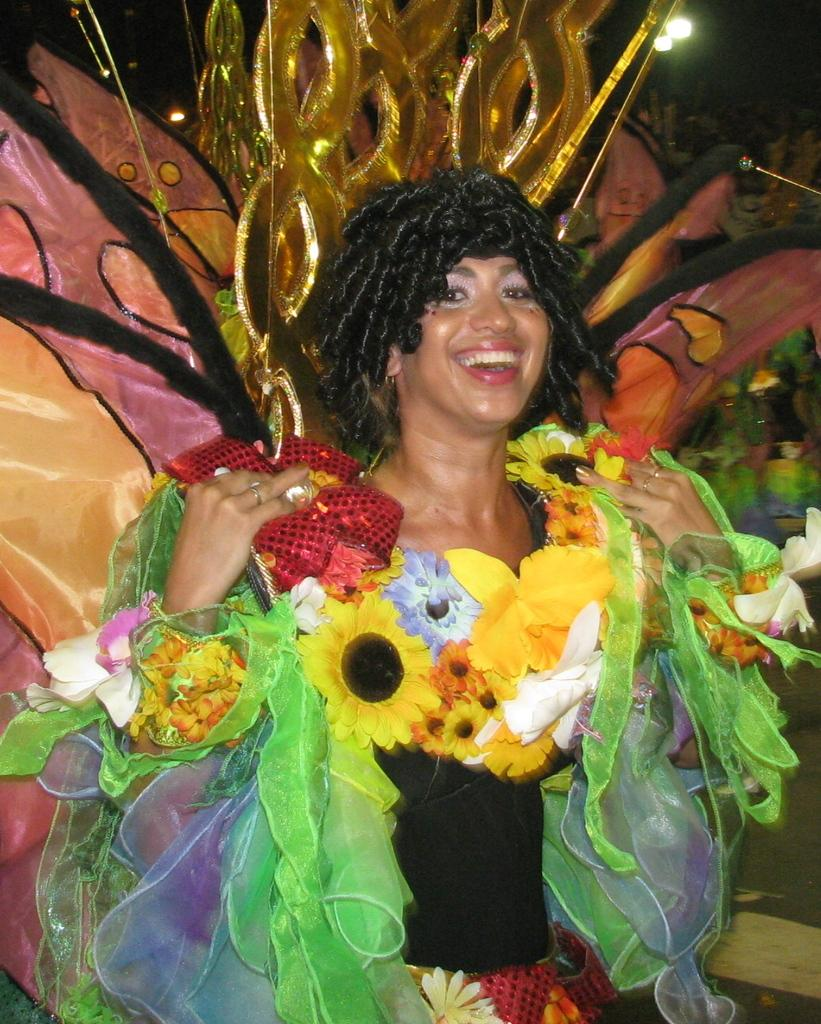Who or what is present in the image? There is a person in the image. What is the person wearing? The person is wearing a costume. What can be seen beneath the person's feet in the image? The ground is visible in the image. Can you tell me how deep the river is in the image? There is no river present in the image; it features a person wearing a costume and the ground visible beneath their feet. 